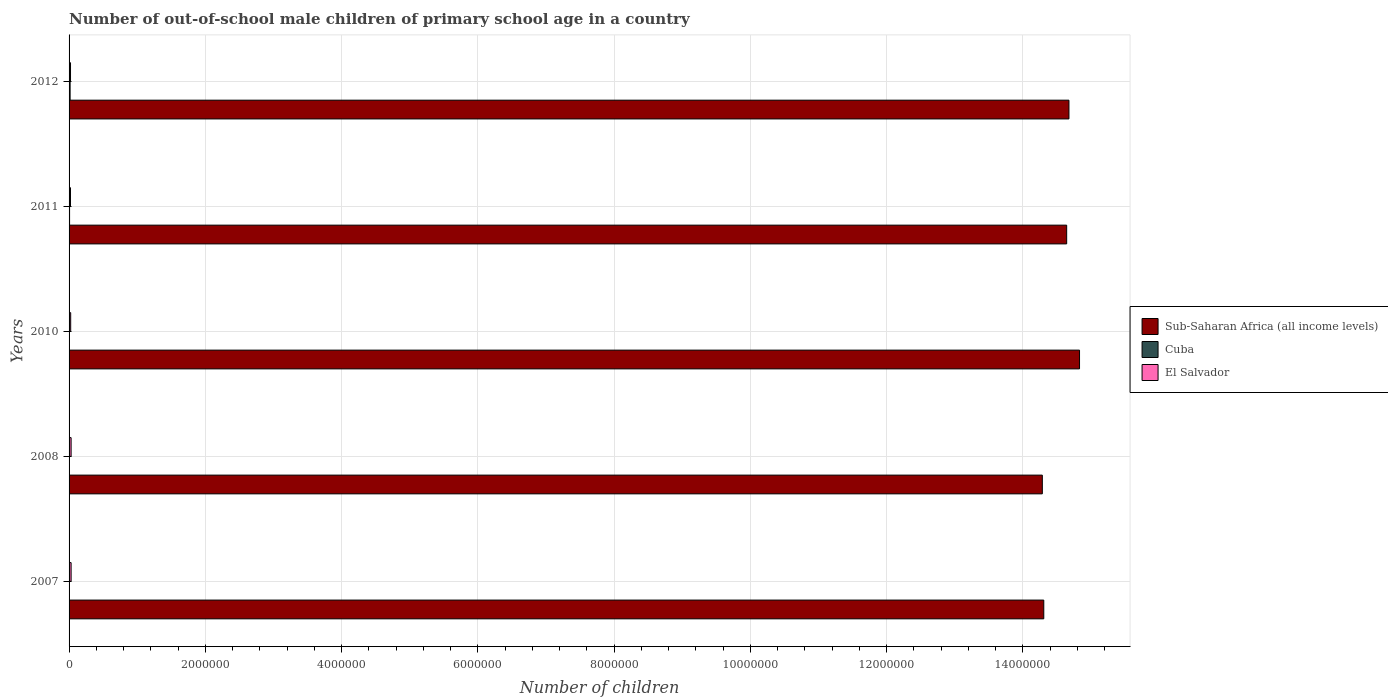Are the number of bars per tick equal to the number of legend labels?
Your response must be concise. Yes. Are the number of bars on each tick of the Y-axis equal?
Provide a short and direct response. Yes. How many bars are there on the 3rd tick from the top?
Provide a succinct answer. 3. How many bars are there on the 1st tick from the bottom?
Give a very brief answer. 3. What is the label of the 5th group of bars from the top?
Make the answer very short. 2007. In how many cases, is the number of bars for a given year not equal to the number of legend labels?
Keep it short and to the point. 0. What is the number of out-of-school male children in El Salvador in 2011?
Your answer should be very brief. 2.07e+04. Across all years, what is the maximum number of out-of-school male children in El Salvador?
Give a very brief answer. 3.00e+04. Across all years, what is the minimum number of out-of-school male children in Cuba?
Your answer should be very brief. 10. What is the total number of out-of-school male children in Cuba in the graph?
Offer a very short reply. 2.72e+04. What is the difference between the number of out-of-school male children in Cuba in 2010 and that in 2012?
Offer a very short reply. -1.51e+04. What is the difference between the number of out-of-school male children in Sub-Saharan Africa (all income levels) in 2008 and the number of out-of-school male children in Cuba in 2007?
Your response must be concise. 1.43e+07. What is the average number of out-of-school male children in Sub-Saharan Africa (all income levels) per year?
Make the answer very short. 1.45e+07. In the year 2010, what is the difference between the number of out-of-school male children in El Salvador and number of out-of-school male children in Cuba?
Provide a succinct answer. 2.36e+04. What is the ratio of the number of out-of-school male children in Sub-Saharan Africa (all income levels) in 2008 to that in 2011?
Your answer should be very brief. 0.98. What is the difference between the highest and the second highest number of out-of-school male children in Sub-Saharan Africa (all income levels)?
Your answer should be very brief. 1.55e+05. What is the difference between the highest and the lowest number of out-of-school male children in Cuba?
Offer a terse response. 1.51e+04. What does the 3rd bar from the top in 2012 represents?
Provide a succinct answer. Sub-Saharan Africa (all income levels). What does the 3rd bar from the bottom in 2011 represents?
Offer a terse response. El Salvador. Is it the case that in every year, the sum of the number of out-of-school male children in El Salvador and number of out-of-school male children in Sub-Saharan Africa (all income levels) is greater than the number of out-of-school male children in Cuba?
Your answer should be very brief. Yes. Are all the bars in the graph horizontal?
Provide a succinct answer. Yes. How many years are there in the graph?
Provide a short and direct response. 5. Are the values on the major ticks of X-axis written in scientific E-notation?
Your answer should be compact. No. Does the graph contain any zero values?
Offer a terse response. No. Does the graph contain grids?
Provide a succinct answer. Yes. Where does the legend appear in the graph?
Offer a very short reply. Center right. How are the legend labels stacked?
Your response must be concise. Vertical. What is the title of the graph?
Offer a very short reply. Number of out-of-school male children of primary school age in a country. What is the label or title of the X-axis?
Your answer should be compact. Number of children. What is the label or title of the Y-axis?
Your answer should be compact. Years. What is the Number of children in Sub-Saharan Africa (all income levels) in 2007?
Your answer should be compact. 1.43e+07. What is the Number of children in Cuba in 2007?
Your response must be concise. 3360. What is the Number of children of El Salvador in 2007?
Make the answer very short. 3.00e+04. What is the Number of children of Sub-Saharan Africa (all income levels) in 2008?
Your response must be concise. 1.43e+07. What is the Number of children in Cuba in 2008?
Provide a short and direct response. 1188. What is the Number of children of El Salvador in 2008?
Give a very brief answer. 3.00e+04. What is the Number of children in Sub-Saharan Africa (all income levels) in 2010?
Your response must be concise. 1.48e+07. What is the Number of children in Cuba in 2010?
Provide a succinct answer. 10. What is the Number of children of El Salvador in 2010?
Provide a short and direct response. 2.36e+04. What is the Number of children of Sub-Saharan Africa (all income levels) in 2011?
Your answer should be very brief. 1.46e+07. What is the Number of children of Cuba in 2011?
Your response must be concise. 7513. What is the Number of children of El Salvador in 2011?
Offer a terse response. 2.07e+04. What is the Number of children of Sub-Saharan Africa (all income levels) in 2012?
Your response must be concise. 1.47e+07. What is the Number of children in Cuba in 2012?
Provide a short and direct response. 1.51e+04. What is the Number of children of El Salvador in 2012?
Keep it short and to the point. 2.13e+04. Across all years, what is the maximum Number of children in Sub-Saharan Africa (all income levels)?
Your answer should be compact. 1.48e+07. Across all years, what is the maximum Number of children of Cuba?
Provide a short and direct response. 1.51e+04. Across all years, what is the maximum Number of children of El Salvador?
Ensure brevity in your answer.  3.00e+04. Across all years, what is the minimum Number of children of Sub-Saharan Africa (all income levels)?
Keep it short and to the point. 1.43e+07. Across all years, what is the minimum Number of children in Cuba?
Offer a terse response. 10. Across all years, what is the minimum Number of children in El Salvador?
Your answer should be very brief. 2.07e+04. What is the total Number of children of Sub-Saharan Africa (all income levels) in the graph?
Provide a succinct answer. 7.27e+07. What is the total Number of children in Cuba in the graph?
Your answer should be compact. 2.72e+04. What is the total Number of children of El Salvador in the graph?
Your answer should be very brief. 1.26e+05. What is the difference between the Number of children of Sub-Saharan Africa (all income levels) in 2007 and that in 2008?
Offer a very short reply. 2.12e+04. What is the difference between the Number of children of Cuba in 2007 and that in 2008?
Your answer should be compact. 2172. What is the difference between the Number of children of El Salvador in 2007 and that in 2008?
Offer a very short reply. -13. What is the difference between the Number of children in Sub-Saharan Africa (all income levels) in 2007 and that in 2010?
Give a very brief answer. -5.25e+05. What is the difference between the Number of children in Cuba in 2007 and that in 2010?
Provide a succinct answer. 3350. What is the difference between the Number of children of El Salvador in 2007 and that in 2010?
Your response must be concise. 6332. What is the difference between the Number of children of Sub-Saharan Africa (all income levels) in 2007 and that in 2011?
Your response must be concise. -3.36e+05. What is the difference between the Number of children of Cuba in 2007 and that in 2011?
Offer a terse response. -4153. What is the difference between the Number of children of El Salvador in 2007 and that in 2011?
Make the answer very short. 9243. What is the difference between the Number of children in Sub-Saharan Africa (all income levels) in 2007 and that in 2012?
Make the answer very short. -3.70e+05. What is the difference between the Number of children of Cuba in 2007 and that in 2012?
Give a very brief answer. -1.18e+04. What is the difference between the Number of children in El Salvador in 2007 and that in 2012?
Offer a very short reply. 8673. What is the difference between the Number of children of Sub-Saharan Africa (all income levels) in 2008 and that in 2010?
Provide a short and direct response. -5.46e+05. What is the difference between the Number of children in Cuba in 2008 and that in 2010?
Your response must be concise. 1178. What is the difference between the Number of children of El Salvador in 2008 and that in 2010?
Provide a succinct answer. 6345. What is the difference between the Number of children of Sub-Saharan Africa (all income levels) in 2008 and that in 2011?
Make the answer very short. -3.57e+05. What is the difference between the Number of children in Cuba in 2008 and that in 2011?
Your answer should be very brief. -6325. What is the difference between the Number of children in El Salvador in 2008 and that in 2011?
Give a very brief answer. 9256. What is the difference between the Number of children of Sub-Saharan Africa (all income levels) in 2008 and that in 2012?
Offer a very short reply. -3.91e+05. What is the difference between the Number of children in Cuba in 2008 and that in 2012?
Provide a short and direct response. -1.40e+04. What is the difference between the Number of children of El Salvador in 2008 and that in 2012?
Provide a short and direct response. 8686. What is the difference between the Number of children of Sub-Saharan Africa (all income levels) in 2010 and that in 2011?
Offer a terse response. 1.89e+05. What is the difference between the Number of children of Cuba in 2010 and that in 2011?
Your response must be concise. -7503. What is the difference between the Number of children of El Salvador in 2010 and that in 2011?
Keep it short and to the point. 2911. What is the difference between the Number of children of Sub-Saharan Africa (all income levels) in 2010 and that in 2012?
Your answer should be compact. 1.55e+05. What is the difference between the Number of children of Cuba in 2010 and that in 2012?
Offer a terse response. -1.51e+04. What is the difference between the Number of children in El Salvador in 2010 and that in 2012?
Provide a succinct answer. 2341. What is the difference between the Number of children of Sub-Saharan Africa (all income levels) in 2011 and that in 2012?
Offer a very short reply. -3.35e+04. What is the difference between the Number of children in Cuba in 2011 and that in 2012?
Offer a terse response. -7633. What is the difference between the Number of children of El Salvador in 2011 and that in 2012?
Your answer should be very brief. -570. What is the difference between the Number of children in Sub-Saharan Africa (all income levels) in 2007 and the Number of children in Cuba in 2008?
Offer a terse response. 1.43e+07. What is the difference between the Number of children of Sub-Saharan Africa (all income levels) in 2007 and the Number of children of El Salvador in 2008?
Give a very brief answer. 1.43e+07. What is the difference between the Number of children in Cuba in 2007 and the Number of children in El Salvador in 2008?
Your response must be concise. -2.66e+04. What is the difference between the Number of children of Sub-Saharan Africa (all income levels) in 2007 and the Number of children of Cuba in 2010?
Give a very brief answer. 1.43e+07. What is the difference between the Number of children of Sub-Saharan Africa (all income levels) in 2007 and the Number of children of El Salvador in 2010?
Your answer should be compact. 1.43e+07. What is the difference between the Number of children of Cuba in 2007 and the Number of children of El Salvador in 2010?
Your answer should be very brief. -2.03e+04. What is the difference between the Number of children of Sub-Saharan Africa (all income levels) in 2007 and the Number of children of Cuba in 2011?
Give a very brief answer. 1.43e+07. What is the difference between the Number of children in Sub-Saharan Africa (all income levels) in 2007 and the Number of children in El Salvador in 2011?
Your response must be concise. 1.43e+07. What is the difference between the Number of children of Cuba in 2007 and the Number of children of El Salvador in 2011?
Offer a very short reply. -1.74e+04. What is the difference between the Number of children in Sub-Saharan Africa (all income levels) in 2007 and the Number of children in Cuba in 2012?
Offer a terse response. 1.43e+07. What is the difference between the Number of children in Sub-Saharan Africa (all income levels) in 2007 and the Number of children in El Salvador in 2012?
Provide a succinct answer. 1.43e+07. What is the difference between the Number of children in Cuba in 2007 and the Number of children in El Salvador in 2012?
Provide a succinct answer. -1.79e+04. What is the difference between the Number of children of Sub-Saharan Africa (all income levels) in 2008 and the Number of children of Cuba in 2010?
Your response must be concise. 1.43e+07. What is the difference between the Number of children in Sub-Saharan Africa (all income levels) in 2008 and the Number of children in El Salvador in 2010?
Offer a terse response. 1.43e+07. What is the difference between the Number of children in Cuba in 2008 and the Number of children in El Salvador in 2010?
Provide a short and direct response. -2.24e+04. What is the difference between the Number of children of Sub-Saharan Africa (all income levels) in 2008 and the Number of children of Cuba in 2011?
Keep it short and to the point. 1.43e+07. What is the difference between the Number of children in Sub-Saharan Africa (all income levels) in 2008 and the Number of children in El Salvador in 2011?
Make the answer very short. 1.43e+07. What is the difference between the Number of children in Cuba in 2008 and the Number of children in El Salvador in 2011?
Provide a succinct answer. -1.95e+04. What is the difference between the Number of children of Sub-Saharan Africa (all income levels) in 2008 and the Number of children of Cuba in 2012?
Your response must be concise. 1.43e+07. What is the difference between the Number of children in Sub-Saharan Africa (all income levels) in 2008 and the Number of children in El Salvador in 2012?
Your response must be concise. 1.43e+07. What is the difference between the Number of children in Cuba in 2008 and the Number of children in El Salvador in 2012?
Make the answer very short. -2.01e+04. What is the difference between the Number of children in Sub-Saharan Africa (all income levels) in 2010 and the Number of children in Cuba in 2011?
Your answer should be very brief. 1.48e+07. What is the difference between the Number of children of Sub-Saharan Africa (all income levels) in 2010 and the Number of children of El Salvador in 2011?
Ensure brevity in your answer.  1.48e+07. What is the difference between the Number of children of Cuba in 2010 and the Number of children of El Salvador in 2011?
Make the answer very short. -2.07e+04. What is the difference between the Number of children of Sub-Saharan Africa (all income levels) in 2010 and the Number of children of Cuba in 2012?
Your response must be concise. 1.48e+07. What is the difference between the Number of children of Sub-Saharan Africa (all income levels) in 2010 and the Number of children of El Salvador in 2012?
Your answer should be compact. 1.48e+07. What is the difference between the Number of children in Cuba in 2010 and the Number of children in El Salvador in 2012?
Your response must be concise. -2.13e+04. What is the difference between the Number of children in Sub-Saharan Africa (all income levels) in 2011 and the Number of children in Cuba in 2012?
Give a very brief answer. 1.46e+07. What is the difference between the Number of children in Sub-Saharan Africa (all income levels) in 2011 and the Number of children in El Salvador in 2012?
Keep it short and to the point. 1.46e+07. What is the difference between the Number of children of Cuba in 2011 and the Number of children of El Salvador in 2012?
Provide a succinct answer. -1.38e+04. What is the average Number of children in Sub-Saharan Africa (all income levels) per year?
Keep it short and to the point. 1.45e+07. What is the average Number of children in Cuba per year?
Keep it short and to the point. 5443.4. What is the average Number of children of El Salvador per year?
Make the answer very short. 2.51e+04. In the year 2007, what is the difference between the Number of children of Sub-Saharan Africa (all income levels) and Number of children of Cuba?
Offer a very short reply. 1.43e+07. In the year 2007, what is the difference between the Number of children in Sub-Saharan Africa (all income levels) and Number of children in El Salvador?
Your answer should be compact. 1.43e+07. In the year 2007, what is the difference between the Number of children in Cuba and Number of children in El Salvador?
Keep it short and to the point. -2.66e+04. In the year 2008, what is the difference between the Number of children in Sub-Saharan Africa (all income levels) and Number of children in Cuba?
Ensure brevity in your answer.  1.43e+07. In the year 2008, what is the difference between the Number of children in Sub-Saharan Africa (all income levels) and Number of children in El Salvador?
Your answer should be very brief. 1.43e+07. In the year 2008, what is the difference between the Number of children in Cuba and Number of children in El Salvador?
Offer a very short reply. -2.88e+04. In the year 2010, what is the difference between the Number of children of Sub-Saharan Africa (all income levels) and Number of children of Cuba?
Your response must be concise. 1.48e+07. In the year 2010, what is the difference between the Number of children of Sub-Saharan Africa (all income levels) and Number of children of El Salvador?
Your answer should be very brief. 1.48e+07. In the year 2010, what is the difference between the Number of children in Cuba and Number of children in El Salvador?
Make the answer very short. -2.36e+04. In the year 2011, what is the difference between the Number of children of Sub-Saharan Africa (all income levels) and Number of children of Cuba?
Offer a very short reply. 1.46e+07. In the year 2011, what is the difference between the Number of children in Sub-Saharan Africa (all income levels) and Number of children in El Salvador?
Provide a short and direct response. 1.46e+07. In the year 2011, what is the difference between the Number of children in Cuba and Number of children in El Salvador?
Offer a terse response. -1.32e+04. In the year 2012, what is the difference between the Number of children of Sub-Saharan Africa (all income levels) and Number of children of Cuba?
Give a very brief answer. 1.47e+07. In the year 2012, what is the difference between the Number of children in Sub-Saharan Africa (all income levels) and Number of children in El Salvador?
Your response must be concise. 1.47e+07. In the year 2012, what is the difference between the Number of children of Cuba and Number of children of El Salvador?
Provide a succinct answer. -6143. What is the ratio of the Number of children of Cuba in 2007 to that in 2008?
Keep it short and to the point. 2.83. What is the ratio of the Number of children of Sub-Saharan Africa (all income levels) in 2007 to that in 2010?
Provide a succinct answer. 0.96. What is the ratio of the Number of children in Cuba in 2007 to that in 2010?
Make the answer very short. 336. What is the ratio of the Number of children of El Salvador in 2007 to that in 2010?
Offer a very short reply. 1.27. What is the ratio of the Number of children in Sub-Saharan Africa (all income levels) in 2007 to that in 2011?
Provide a short and direct response. 0.98. What is the ratio of the Number of children in Cuba in 2007 to that in 2011?
Give a very brief answer. 0.45. What is the ratio of the Number of children in El Salvador in 2007 to that in 2011?
Your answer should be very brief. 1.45. What is the ratio of the Number of children of Sub-Saharan Africa (all income levels) in 2007 to that in 2012?
Keep it short and to the point. 0.97. What is the ratio of the Number of children of Cuba in 2007 to that in 2012?
Offer a very short reply. 0.22. What is the ratio of the Number of children in El Salvador in 2007 to that in 2012?
Offer a very short reply. 1.41. What is the ratio of the Number of children in Sub-Saharan Africa (all income levels) in 2008 to that in 2010?
Ensure brevity in your answer.  0.96. What is the ratio of the Number of children of Cuba in 2008 to that in 2010?
Your answer should be very brief. 118.8. What is the ratio of the Number of children of El Salvador in 2008 to that in 2010?
Provide a succinct answer. 1.27. What is the ratio of the Number of children of Sub-Saharan Africa (all income levels) in 2008 to that in 2011?
Your response must be concise. 0.98. What is the ratio of the Number of children in Cuba in 2008 to that in 2011?
Provide a succinct answer. 0.16. What is the ratio of the Number of children in El Salvador in 2008 to that in 2011?
Make the answer very short. 1.45. What is the ratio of the Number of children of Sub-Saharan Africa (all income levels) in 2008 to that in 2012?
Give a very brief answer. 0.97. What is the ratio of the Number of children of Cuba in 2008 to that in 2012?
Offer a terse response. 0.08. What is the ratio of the Number of children of El Salvador in 2008 to that in 2012?
Offer a very short reply. 1.41. What is the ratio of the Number of children in Sub-Saharan Africa (all income levels) in 2010 to that in 2011?
Offer a very short reply. 1.01. What is the ratio of the Number of children in Cuba in 2010 to that in 2011?
Make the answer very short. 0. What is the ratio of the Number of children in El Salvador in 2010 to that in 2011?
Ensure brevity in your answer.  1.14. What is the ratio of the Number of children of Sub-Saharan Africa (all income levels) in 2010 to that in 2012?
Keep it short and to the point. 1.01. What is the ratio of the Number of children of Cuba in 2010 to that in 2012?
Give a very brief answer. 0. What is the ratio of the Number of children of El Salvador in 2010 to that in 2012?
Provide a succinct answer. 1.11. What is the ratio of the Number of children of Sub-Saharan Africa (all income levels) in 2011 to that in 2012?
Keep it short and to the point. 1. What is the ratio of the Number of children in Cuba in 2011 to that in 2012?
Your response must be concise. 0.5. What is the ratio of the Number of children in El Salvador in 2011 to that in 2012?
Provide a succinct answer. 0.97. What is the difference between the highest and the second highest Number of children in Sub-Saharan Africa (all income levels)?
Give a very brief answer. 1.55e+05. What is the difference between the highest and the second highest Number of children of Cuba?
Make the answer very short. 7633. What is the difference between the highest and the lowest Number of children of Sub-Saharan Africa (all income levels)?
Give a very brief answer. 5.46e+05. What is the difference between the highest and the lowest Number of children of Cuba?
Your answer should be compact. 1.51e+04. What is the difference between the highest and the lowest Number of children of El Salvador?
Provide a short and direct response. 9256. 